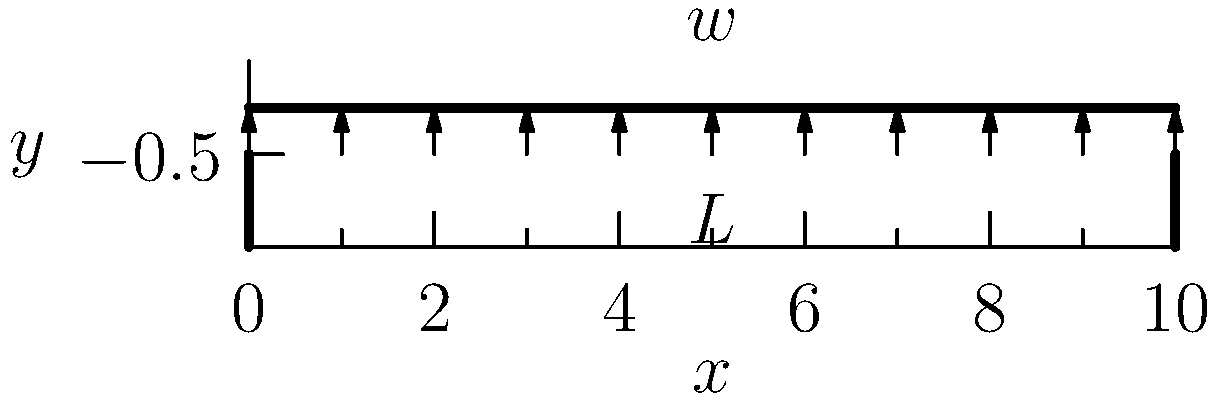A mine shaft support beam of length $L$ is subjected to a uniformly distributed load $w$ per unit length. Determine the maximum bending moment in the beam. To find the maximum bending moment in a simply supported beam with a uniformly distributed load, we can follow these steps:

1. Identify the beam configuration:
   - Length: $L$
   - Uniformly distributed load: $w$ per unit length

2. Calculate the total load on the beam:
   $P = w \cdot L$

3. Determine the reaction forces at the supports:
   Due to symmetry, each support bears half of the total load.
   $R_A = R_B = \frac{P}{2} = \frac{wL}{2}$

4. The bending moment equation for a beam with a uniformly distributed load is:
   $M(x) = \frac{wx}{2}(L-x)$

5. To find the maximum bending moment, we need to find the point where $\frac{dM}{dx} = 0$:
   $\frac{dM}{dx} = \frac{w}{2}(L-2x) = 0$

6. Solving for x:
   $L-2x = 0$
   $x = \frac{L}{2}$

7. The maximum bending moment occurs at the center of the beam $(x = \frac{L}{2})$. Substituting this into the moment equation:
   $M_{max} = \frac{w(\frac{L}{2})}{2}(L-\frac{L}{2}) = \frac{wL^2}{8}$

Therefore, the maximum bending moment in the beam is $\frac{wL^2}{8}$.
Answer: $\frac{wL^2}{8}$ 